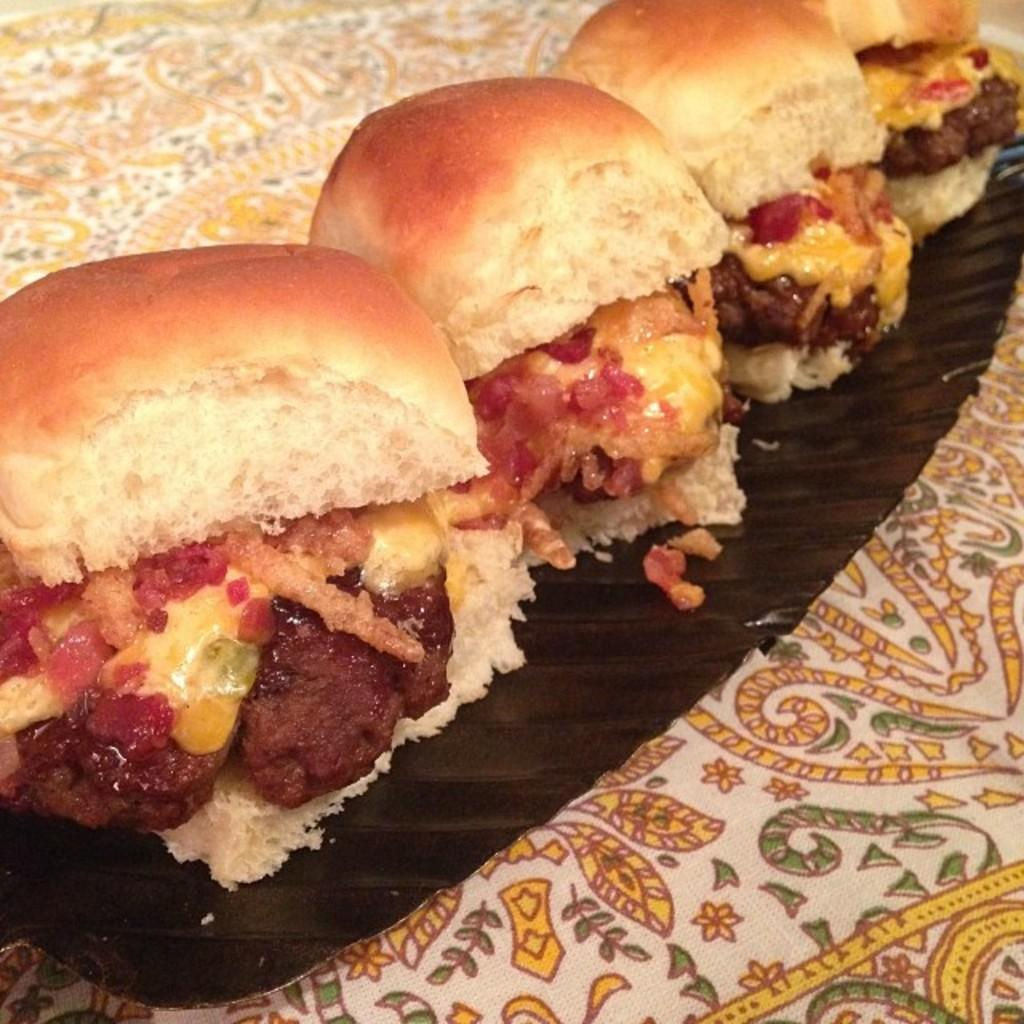What is on the plate that is visible in the image? There are buns on the plate in the image. What else can be seen on the plate besides the buns? There are other food items on the plate. Where is the plate located in the image? The plate is on a cloth in the image. What type of committee is meeting in the image? There is no committee meeting in the image; it features a plate with buns and other food items on a cloth. 